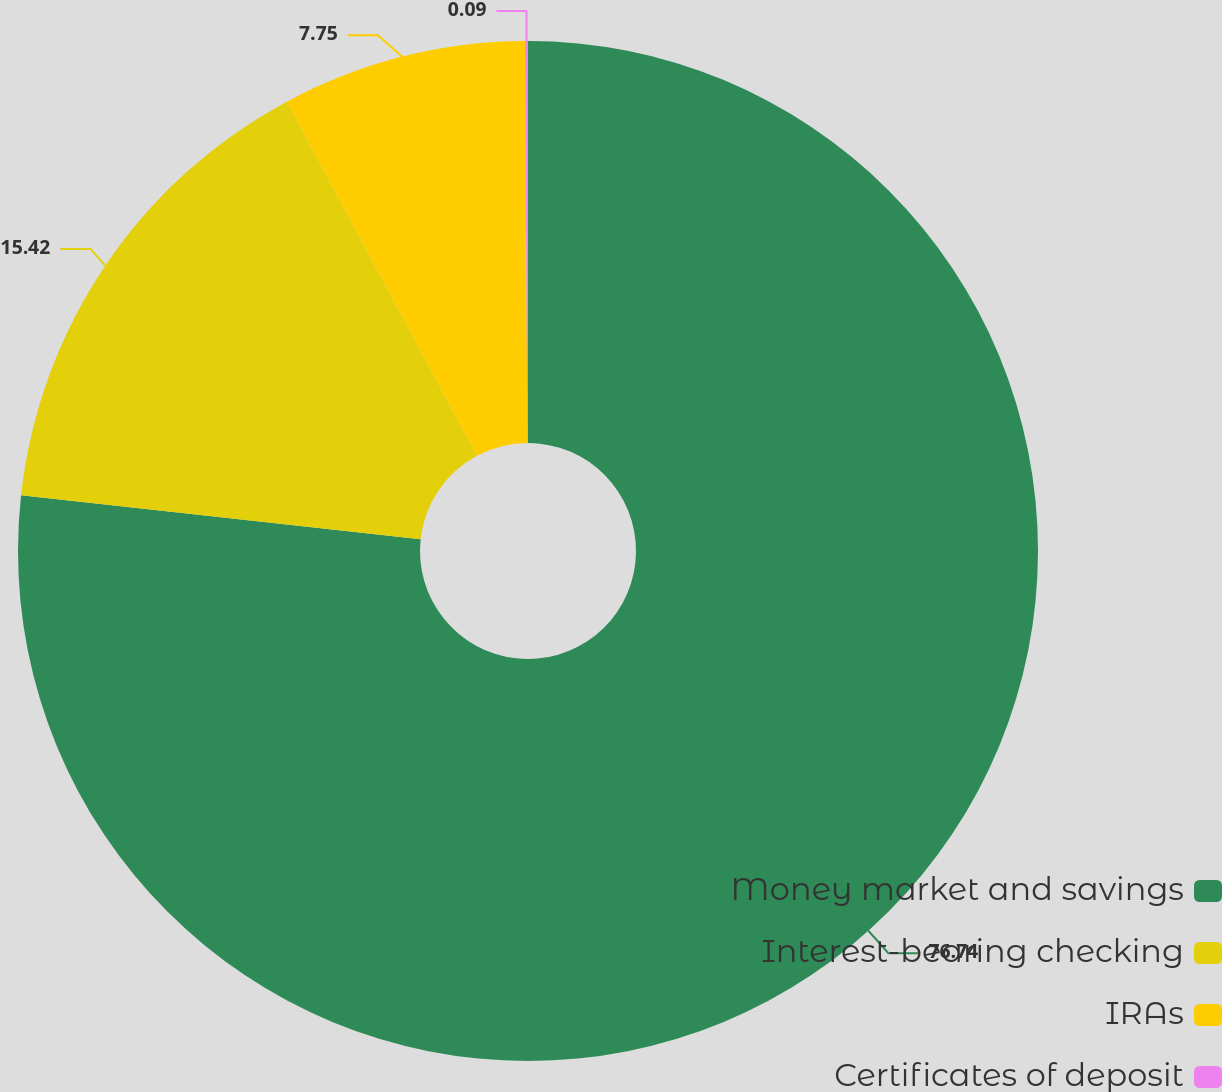<chart> <loc_0><loc_0><loc_500><loc_500><pie_chart><fcel>Money market and savings<fcel>Interest-bearing checking<fcel>IRAs<fcel>Certificates of deposit<nl><fcel>76.74%<fcel>15.42%<fcel>7.75%<fcel>0.09%<nl></chart> 